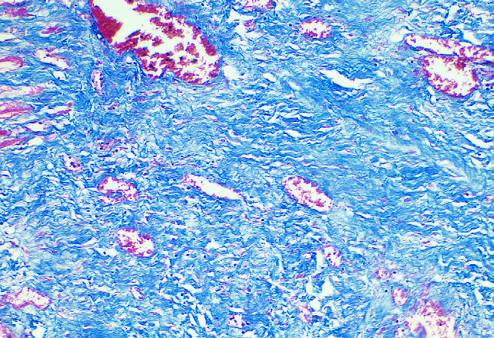s the injurious stimulus stained blue by the trichrome stain?
Answer the question using a single word or phrase. No 